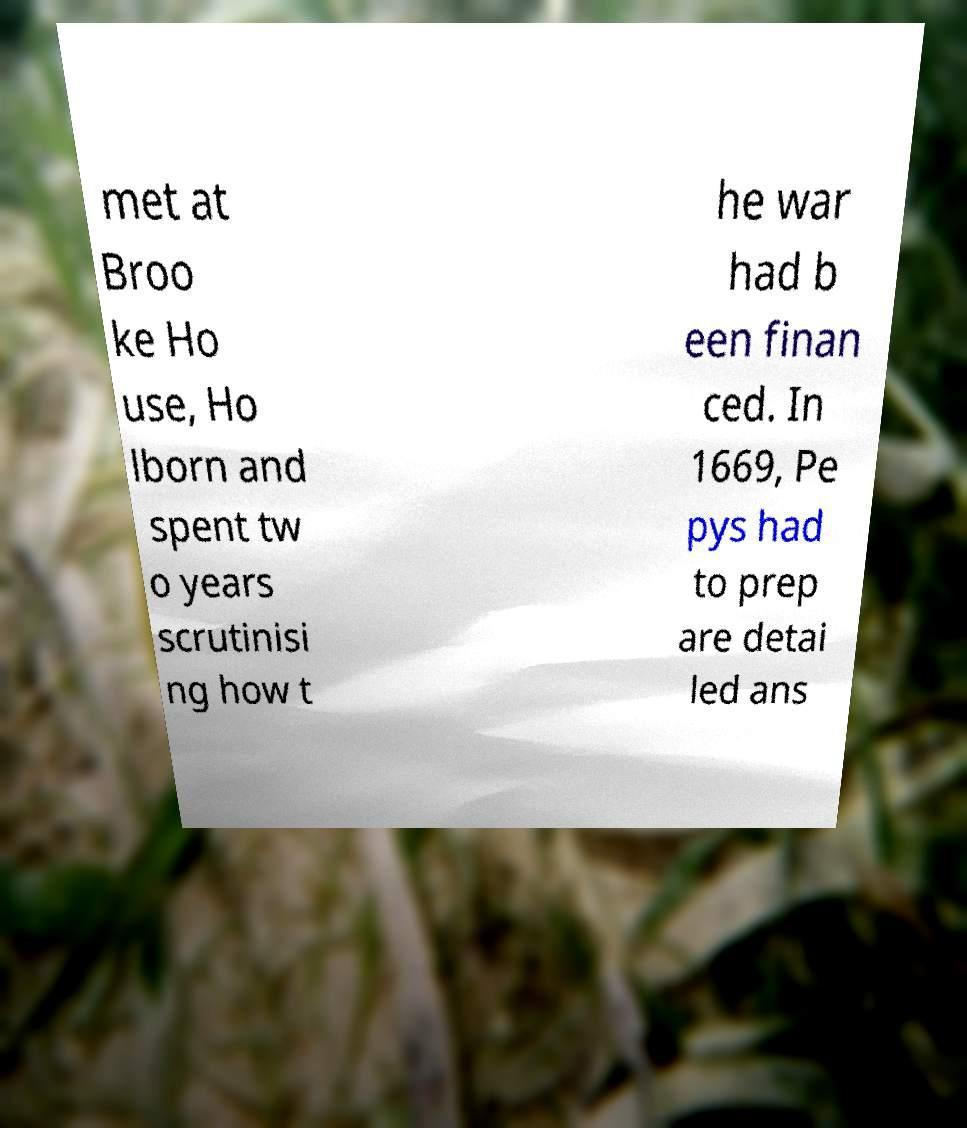Please identify and transcribe the text found in this image. met at Broo ke Ho use, Ho lborn and spent tw o years scrutinisi ng how t he war had b een finan ced. In 1669, Pe pys had to prep are detai led ans 